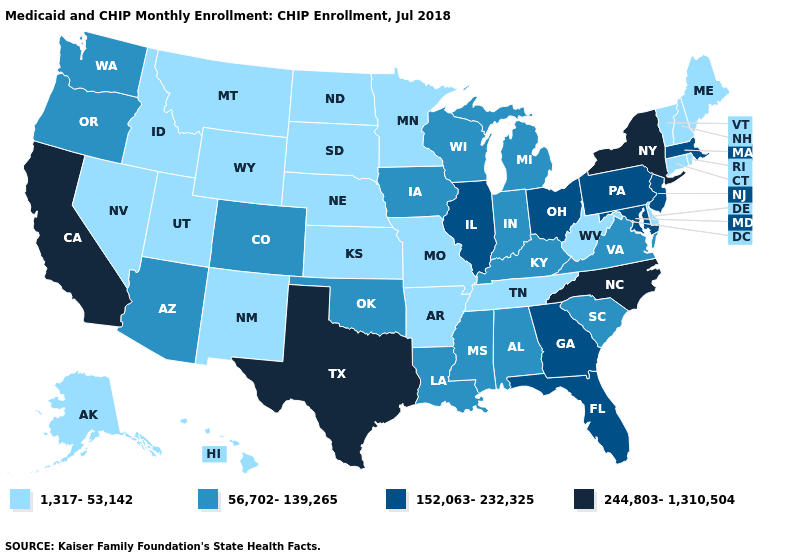What is the value of Indiana?
Concise answer only. 56,702-139,265. Is the legend a continuous bar?
Be succinct. No. What is the highest value in the USA?
Answer briefly. 244,803-1,310,504. Name the states that have a value in the range 56,702-139,265?
Write a very short answer. Alabama, Arizona, Colorado, Indiana, Iowa, Kentucky, Louisiana, Michigan, Mississippi, Oklahoma, Oregon, South Carolina, Virginia, Washington, Wisconsin. Name the states that have a value in the range 244,803-1,310,504?
Be succinct. California, New York, North Carolina, Texas. Which states have the lowest value in the USA?
Quick response, please. Alaska, Arkansas, Connecticut, Delaware, Hawaii, Idaho, Kansas, Maine, Minnesota, Missouri, Montana, Nebraska, Nevada, New Hampshire, New Mexico, North Dakota, Rhode Island, South Dakota, Tennessee, Utah, Vermont, West Virginia, Wyoming. What is the value of Tennessee?
Give a very brief answer. 1,317-53,142. What is the value of Kansas?
Concise answer only. 1,317-53,142. Is the legend a continuous bar?
Concise answer only. No. What is the value of Minnesota?
Answer briefly. 1,317-53,142. Does Idaho have the same value as Michigan?
Concise answer only. No. Name the states that have a value in the range 152,063-232,325?
Quick response, please. Florida, Georgia, Illinois, Maryland, Massachusetts, New Jersey, Ohio, Pennsylvania. What is the highest value in the USA?
Short answer required. 244,803-1,310,504. What is the highest value in the South ?
Concise answer only. 244,803-1,310,504. Does the first symbol in the legend represent the smallest category?
Quick response, please. Yes. 